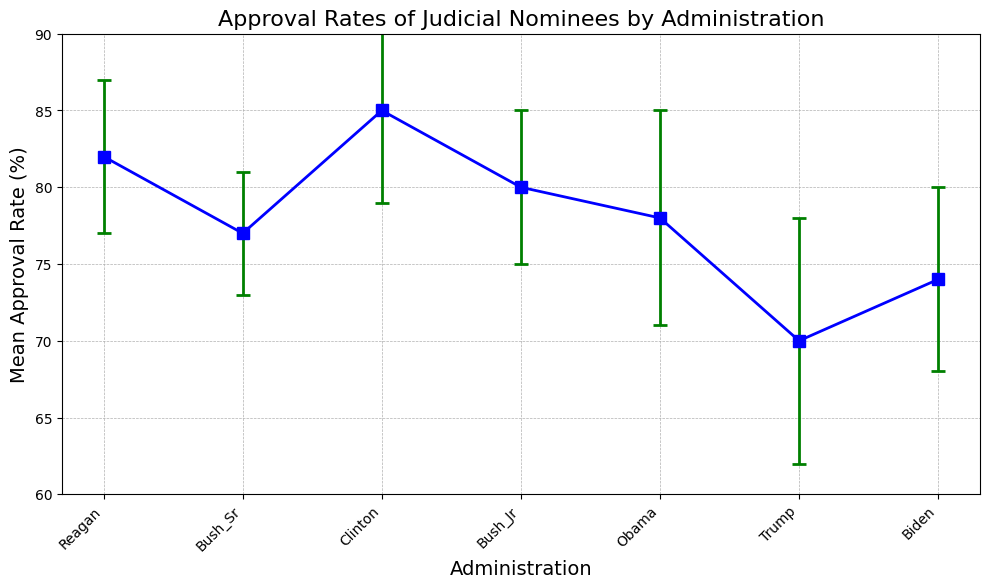what is the mean approval rate for Trump's administration? To find the mean approval rate for Trump's administration, look at the data point for Trump on the x-axis. The corresponding y-value represents the approval rate, which is 70.
Answer: 70 Which administration has the highest mean approval rate for judicial nominees? To identify this, examine the y-values of all data points. The administration with the highest y-value (mean approval rate) is Clinton with a rate of 85.
Answer: Clinton How does Reagan's standard deviation compare to Obama's standard deviation? Look at the error bars on Reagan's and Obama's approval rates. Reagan has a standard deviation of 5, while Obama has a standard deviation of 7. Reagan’s standard deviation is smaller than Obama’s.
Answer: Reagan's standard deviation is smaller Which administration has the smallest mean approval rate, and what is that rate? Examine the y-values for all administrations. The smallest mean approval rate is for Trump, which is 70.
Answer: Trump, 70 What is the range of the mean approval rates presented in the plot? Calculate the difference between the highest and lowest mean approval rates. The highest is Clinton with 85, and the lowest is Trump with 70. The range is 85 - 70 = 15.
Answer: 15 Which administration has the largest error bar, indicating the highest standard deviation? Look at the length of the error bars for all administrations. The longest error bar is for Trump, indicating the highest standard deviation of 8.
Answer: Trump Calculate the average mean approval rate across all administrations. Sum the mean approval rates of all administrations (82 + 77 + 85 + 80 + 78 + 70 + 74), which equals 546. Divide by the number of administrations (7). The average is 546/7 ≈ 78.
Answer: 78 Compared to Reagan's administration, how much lower is the mean approval rate for Biden's administration? Find the difference between the two mean approval rates. Reagan's is 82, and Biden’s is 74. The difference is 82 - 74 = 8.
Answer: 8 What is the mean and standard deviation of approval rates for Bush Sr. and Bush Jr.? To find the mean, add the approval rates of both administrations (77 + 80) and divide by 2: (77 + 80)/2 = 78.5. For the average standard deviation, add their standard deviations (4 + 5) and divide by 2: (4 + 5)/2 = 4.5.
Answer: Mean: 78.5, Std Dev: 4.5 